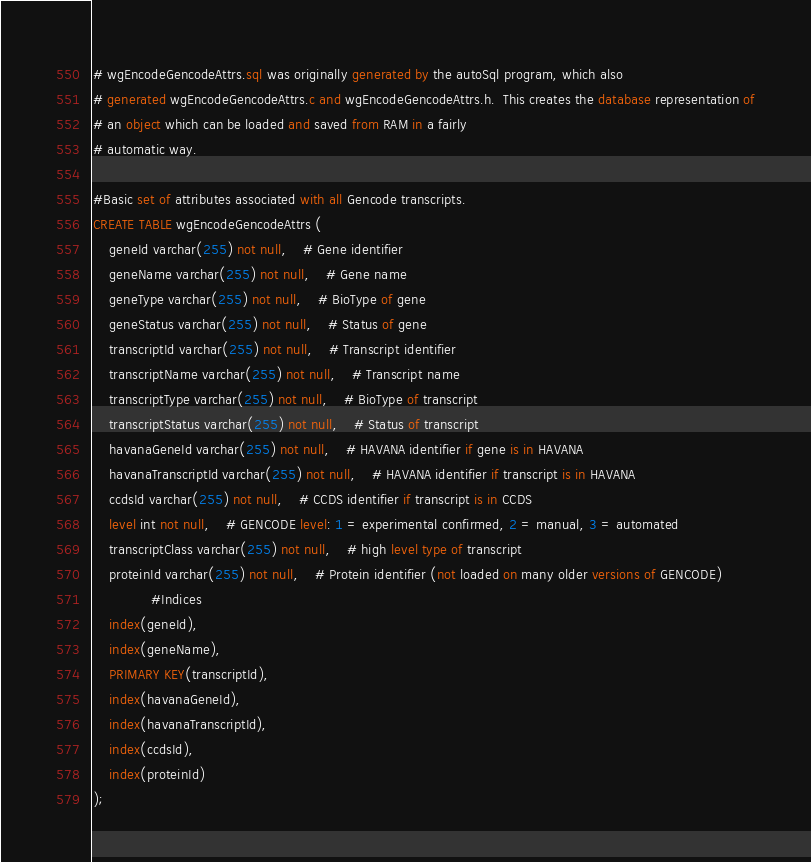Convert code to text. <code><loc_0><loc_0><loc_500><loc_500><_SQL_># wgEncodeGencodeAttrs.sql was originally generated by the autoSql program, which also 
# generated wgEncodeGencodeAttrs.c and wgEncodeGencodeAttrs.h.  This creates the database representation of
# an object which can be loaded and saved from RAM in a fairly 
# automatic way.

#Basic set of attributes associated with all Gencode transcripts.
CREATE TABLE wgEncodeGencodeAttrs (
    geneId varchar(255) not null,	# Gene identifier
    geneName varchar(255) not null,	# Gene name
    geneType varchar(255) not null,	# BioType of gene
    geneStatus varchar(255) not null,	# Status of gene
    transcriptId varchar(255) not null,	# Transcript identifier
    transcriptName varchar(255) not null,	# Transcript name
    transcriptType varchar(255) not null,	# BioType of transcript
    transcriptStatus varchar(255) not null,	# Status of transcript
    havanaGeneId varchar(255) not null,	# HAVANA identifier if gene is in HAVANA
    havanaTranscriptId varchar(255) not null,	# HAVANA identifier if transcript is in HAVANA
    ccdsId varchar(255) not null,	# CCDS identifier if transcript is in CCDS
    level int not null,	# GENCODE level: 1 = experimental confirmed, 2 = manual, 3 = automated
    transcriptClass varchar(255) not null,	# high level type of transcript
    proteinId varchar(255) not null,	# Protein identifier (not loaded on many older versions of GENCODE)
              #Indices
    index(geneId),
    index(geneName),
    PRIMARY KEY(transcriptId),
    index(havanaGeneId),
    index(havanaTranscriptId),
    index(ccdsId),
    index(proteinId)
);
</code> 